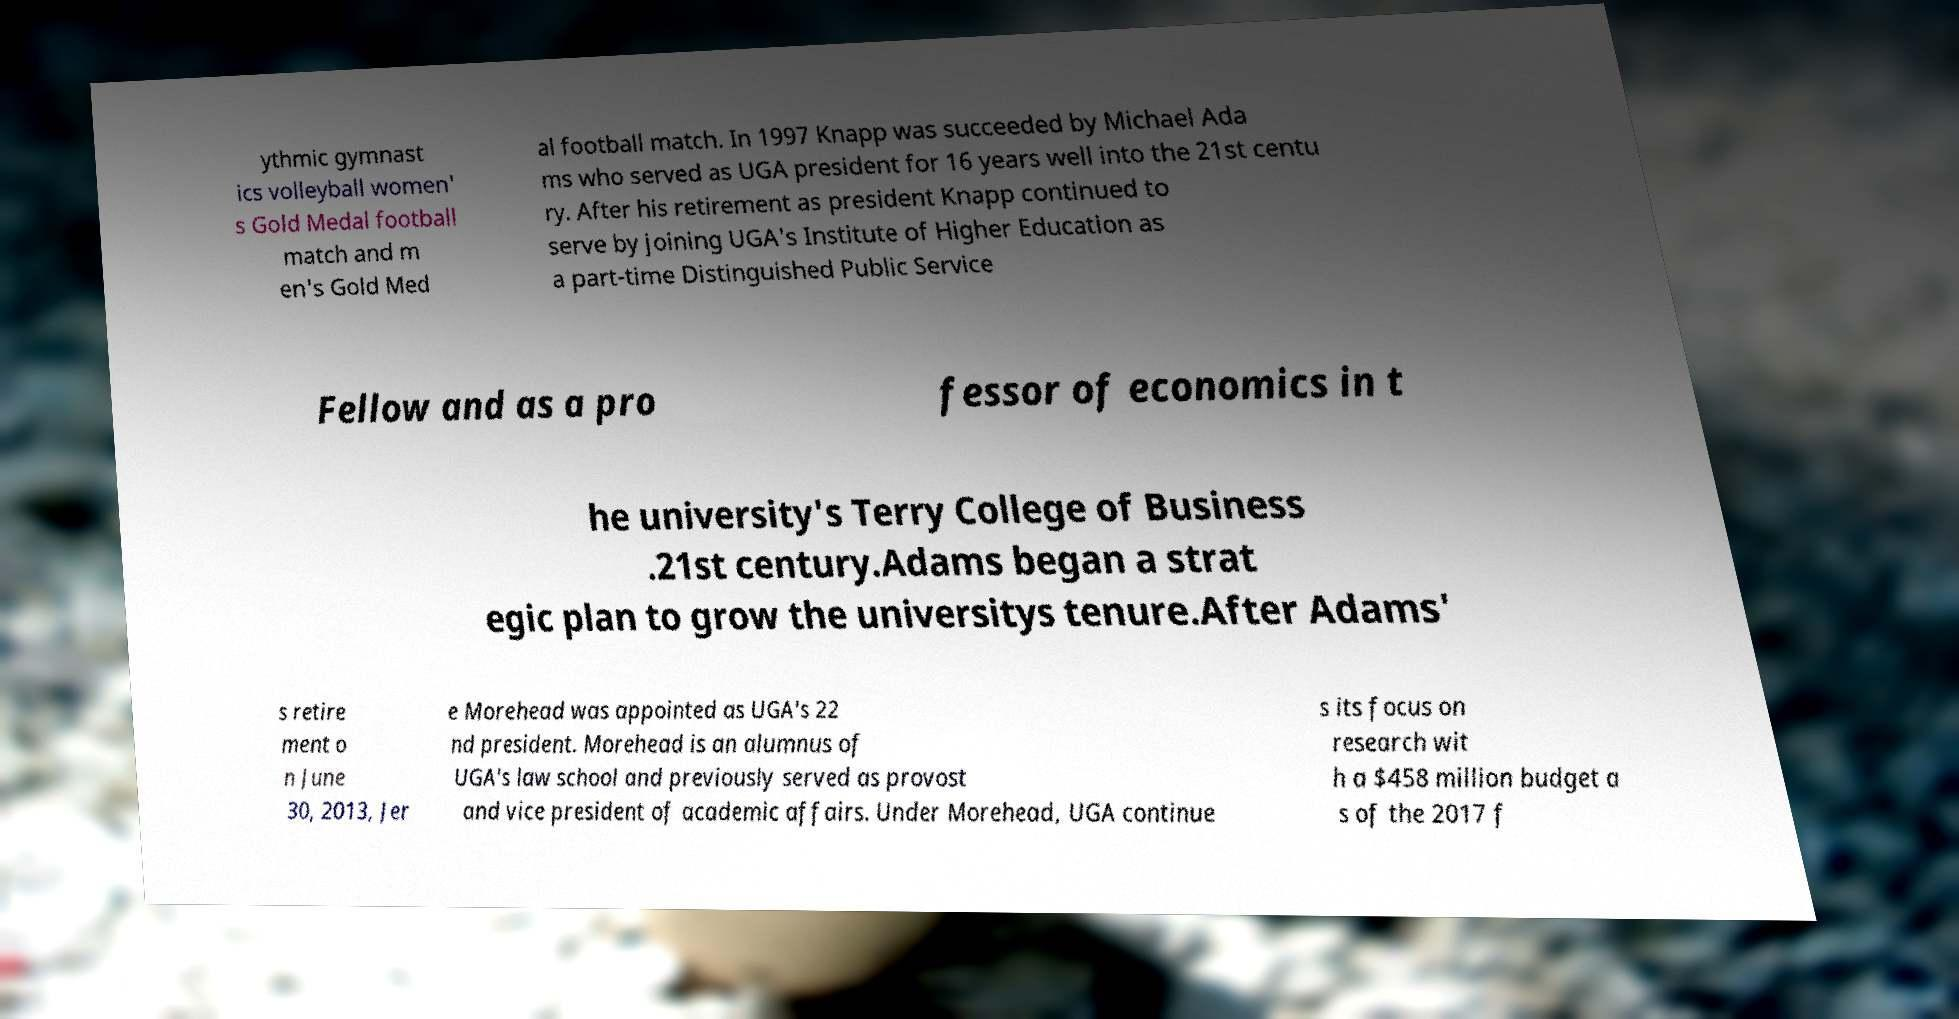I need the written content from this picture converted into text. Can you do that? ythmic gymnast ics volleyball women' s Gold Medal football match and m en's Gold Med al football match. In 1997 Knapp was succeeded by Michael Ada ms who served as UGA president for 16 years well into the 21st centu ry. After his retirement as president Knapp continued to serve by joining UGA's Institute of Higher Education as a part-time Distinguished Public Service Fellow and as a pro fessor of economics in t he university's Terry College of Business .21st century.Adams began a strat egic plan to grow the universitys tenure.After Adams' s retire ment o n June 30, 2013, Jer e Morehead was appointed as UGA's 22 nd president. Morehead is an alumnus of UGA's law school and previously served as provost and vice president of academic affairs. Under Morehead, UGA continue s its focus on research wit h a $458 million budget a s of the 2017 f 